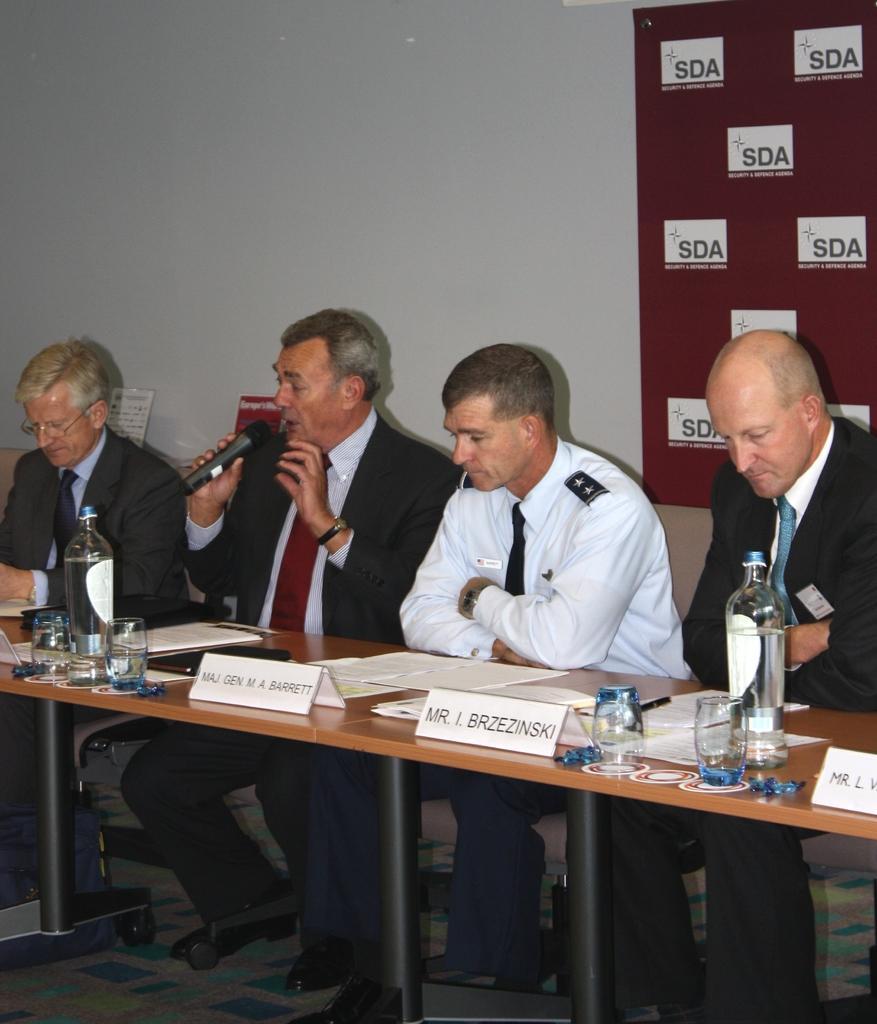Could you give a brief overview of what you see in this image? In this image there are group of persons who are sitting on the chairs and in front of them there are bottles,glasses on top of the table. 